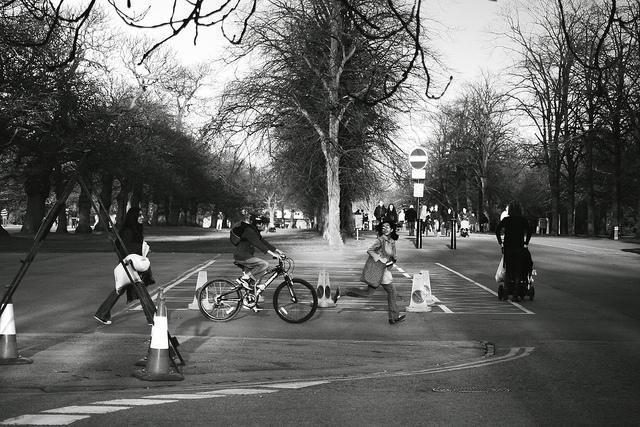How many people are there?
Give a very brief answer. 3. 